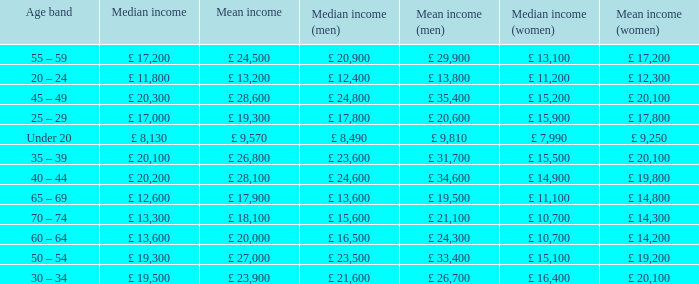Name the median income for age band being under 20 £ 8,130. Parse the table in full. {'header': ['Age band', 'Median income', 'Mean income', 'Median income (men)', 'Mean income (men)', 'Median income (women)', 'Mean income (women)'], 'rows': [['55 – 59', '£ 17,200', '£ 24,500', '£ 20,900', '£ 29,900', '£ 13,100', '£ 17,200'], ['20 – 24', '£ 11,800', '£ 13,200', '£ 12,400', '£ 13,800', '£ 11,200', '£ 12,300'], ['45 – 49', '£ 20,300', '£ 28,600', '£ 24,800', '£ 35,400', '£ 15,200', '£ 20,100'], ['25 – 29', '£ 17,000', '£ 19,300', '£ 17,800', '£ 20,600', '£ 15,900', '£ 17,800'], ['Under 20', '£ 8,130', '£ 9,570', '£ 8,490', '£ 9,810', '£ 7,990', '£ 9,250'], ['35 – 39', '£ 20,100', '£ 26,800', '£ 23,600', '£ 31,700', '£ 15,500', '£ 20,100'], ['40 – 44', '£ 20,200', '£ 28,100', '£ 24,600', '£ 34,600', '£ 14,900', '£ 19,800'], ['65 – 69', '£ 12,600', '£ 17,900', '£ 13,600', '£ 19,500', '£ 11,100', '£ 14,800'], ['70 – 74', '£ 13,300', '£ 18,100', '£ 15,600', '£ 21,100', '£ 10,700', '£ 14,300'], ['60 – 64', '£ 13,600', '£ 20,000', '£ 16,500', '£ 24,300', '£ 10,700', '£ 14,200'], ['50 – 54', '£ 19,300', '£ 27,000', '£ 23,500', '£ 33,400', '£ 15,100', '£ 19,200'], ['30 – 34', '£ 19,500', '£ 23,900', '£ 21,600', '£ 26,700', '£ 16,400', '£ 20,100']]} 